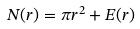<formula> <loc_0><loc_0><loc_500><loc_500>N ( r ) = \pi r ^ { 2 } + E ( r )</formula> 